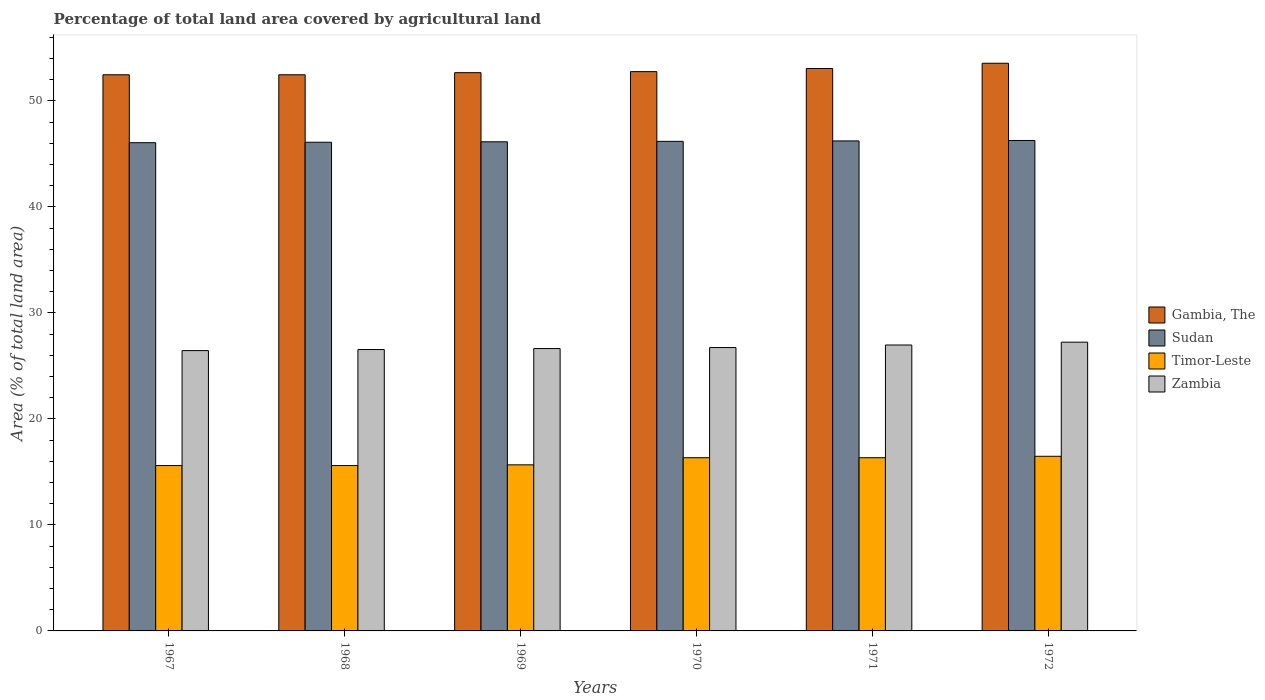Are the number of bars per tick equal to the number of legend labels?
Make the answer very short. Yes. Are the number of bars on each tick of the X-axis equal?
Give a very brief answer. Yes. How many bars are there on the 1st tick from the left?
Your response must be concise. 4. How many bars are there on the 2nd tick from the right?
Give a very brief answer. 4. What is the label of the 2nd group of bars from the left?
Provide a succinct answer. 1968. In how many cases, is the number of bars for a given year not equal to the number of legend labels?
Make the answer very short. 0. What is the percentage of agricultural land in Gambia, The in 1967?
Offer a very short reply. 52.47. Across all years, what is the maximum percentage of agricultural land in Gambia, The?
Offer a very short reply. 53.56. Across all years, what is the minimum percentage of agricultural land in Gambia, The?
Your answer should be very brief. 52.47. In which year was the percentage of agricultural land in Sudan minimum?
Provide a short and direct response. 1967. What is the total percentage of agricultural land in Gambia, The in the graph?
Offer a terse response. 317. What is the difference between the percentage of agricultural land in Zambia in 1967 and that in 1970?
Offer a very short reply. -0.29. What is the difference between the percentage of agricultural land in Sudan in 1968 and the percentage of agricultural land in Zambia in 1969?
Ensure brevity in your answer.  19.47. What is the average percentage of agricultural land in Zambia per year?
Your answer should be compact. 26.76. In the year 1967, what is the difference between the percentage of agricultural land in Sudan and percentage of agricultural land in Gambia, The?
Offer a terse response. -6.41. What is the ratio of the percentage of agricultural land in Sudan in 1971 to that in 1972?
Offer a terse response. 1. Is the percentage of agricultural land in Gambia, The in 1971 less than that in 1972?
Make the answer very short. Yes. What is the difference between the highest and the second highest percentage of agricultural land in Gambia, The?
Give a very brief answer. 0.49. What is the difference between the highest and the lowest percentage of agricultural land in Sudan?
Your answer should be very brief. 0.21. Is the sum of the percentage of agricultural land in Gambia, The in 1969 and 1972 greater than the maximum percentage of agricultural land in Timor-Leste across all years?
Ensure brevity in your answer.  Yes. Is it the case that in every year, the sum of the percentage of agricultural land in Zambia and percentage of agricultural land in Timor-Leste is greater than the sum of percentage of agricultural land in Sudan and percentage of agricultural land in Gambia, The?
Your answer should be very brief. No. What does the 3rd bar from the left in 1967 represents?
Ensure brevity in your answer.  Timor-Leste. What does the 1st bar from the right in 1969 represents?
Your answer should be compact. Zambia. Is it the case that in every year, the sum of the percentage of agricultural land in Sudan and percentage of agricultural land in Timor-Leste is greater than the percentage of agricultural land in Zambia?
Your response must be concise. Yes. How many bars are there?
Make the answer very short. 24. How many years are there in the graph?
Make the answer very short. 6. Are the values on the major ticks of Y-axis written in scientific E-notation?
Provide a succinct answer. No. How many legend labels are there?
Ensure brevity in your answer.  4. How are the legend labels stacked?
Your response must be concise. Vertical. What is the title of the graph?
Keep it short and to the point. Percentage of total land area covered by agricultural land. Does "Papua New Guinea" appear as one of the legend labels in the graph?
Keep it short and to the point. No. What is the label or title of the Y-axis?
Your answer should be very brief. Area (% of total land area). What is the Area (% of total land area) in Gambia, The in 1967?
Offer a very short reply. 52.47. What is the Area (% of total land area) in Sudan in 1967?
Provide a short and direct response. 46.06. What is the Area (% of total land area) of Timor-Leste in 1967?
Your response must be concise. 15.6. What is the Area (% of total land area) of Zambia in 1967?
Your answer should be very brief. 26.45. What is the Area (% of total land area) in Gambia, The in 1968?
Your answer should be compact. 52.47. What is the Area (% of total land area) in Sudan in 1968?
Offer a terse response. 46.11. What is the Area (% of total land area) in Timor-Leste in 1968?
Offer a terse response. 15.6. What is the Area (% of total land area) in Zambia in 1968?
Offer a very short reply. 26.55. What is the Area (% of total land area) in Gambia, The in 1969?
Provide a short and direct response. 52.67. What is the Area (% of total land area) in Sudan in 1969?
Your answer should be compact. 46.15. What is the Area (% of total land area) in Timor-Leste in 1969?
Ensure brevity in your answer.  15.67. What is the Area (% of total land area) of Zambia in 1969?
Your answer should be very brief. 26.64. What is the Area (% of total land area) of Gambia, The in 1970?
Give a very brief answer. 52.77. What is the Area (% of total land area) in Sudan in 1970?
Ensure brevity in your answer.  46.19. What is the Area (% of total land area) of Timor-Leste in 1970?
Ensure brevity in your answer.  16.34. What is the Area (% of total land area) of Zambia in 1970?
Your answer should be very brief. 26.73. What is the Area (% of total land area) of Gambia, The in 1971?
Give a very brief answer. 53.06. What is the Area (% of total land area) in Sudan in 1971?
Ensure brevity in your answer.  46.23. What is the Area (% of total land area) of Timor-Leste in 1971?
Provide a short and direct response. 16.34. What is the Area (% of total land area) in Zambia in 1971?
Keep it short and to the point. 26.98. What is the Area (% of total land area) in Gambia, The in 1972?
Make the answer very short. 53.56. What is the Area (% of total land area) of Sudan in 1972?
Make the answer very short. 46.27. What is the Area (% of total land area) of Timor-Leste in 1972?
Make the answer very short. 16.48. What is the Area (% of total land area) in Zambia in 1972?
Make the answer very short. 27.24. Across all years, what is the maximum Area (% of total land area) of Gambia, The?
Provide a short and direct response. 53.56. Across all years, what is the maximum Area (% of total land area) of Sudan?
Your answer should be very brief. 46.27. Across all years, what is the maximum Area (% of total land area) in Timor-Leste?
Make the answer very short. 16.48. Across all years, what is the maximum Area (% of total land area) of Zambia?
Ensure brevity in your answer.  27.24. Across all years, what is the minimum Area (% of total land area) in Gambia, The?
Give a very brief answer. 52.47. Across all years, what is the minimum Area (% of total land area) of Sudan?
Your answer should be compact. 46.06. Across all years, what is the minimum Area (% of total land area) in Timor-Leste?
Provide a succinct answer. 15.6. Across all years, what is the minimum Area (% of total land area) in Zambia?
Provide a succinct answer. 26.45. What is the total Area (% of total land area) of Gambia, The in the graph?
Make the answer very short. 317. What is the total Area (% of total land area) in Sudan in the graph?
Your answer should be compact. 277.01. What is the total Area (% of total land area) in Timor-Leste in the graph?
Provide a short and direct response. 96.03. What is the total Area (% of total land area) of Zambia in the graph?
Your answer should be compact. 160.59. What is the difference between the Area (% of total land area) in Sudan in 1967 and that in 1968?
Make the answer very short. -0.04. What is the difference between the Area (% of total land area) in Timor-Leste in 1967 and that in 1968?
Give a very brief answer. 0. What is the difference between the Area (% of total land area) in Zambia in 1967 and that in 1968?
Offer a very short reply. -0.1. What is the difference between the Area (% of total land area) of Gambia, The in 1967 and that in 1969?
Offer a very short reply. -0.2. What is the difference between the Area (% of total land area) of Sudan in 1967 and that in 1969?
Keep it short and to the point. -0.08. What is the difference between the Area (% of total land area) in Timor-Leste in 1967 and that in 1969?
Your response must be concise. -0.07. What is the difference between the Area (% of total land area) of Zambia in 1967 and that in 1969?
Your response must be concise. -0.19. What is the difference between the Area (% of total land area) in Gambia, The in 1967 and that in 1970?
Your answer should be compact. -0.3. What is the difference between the Area (% of total land area) in Sudan in 1967 and that in 1970?
Your answer should be very brief. -0.12. What is the difference between the Area (% of total land area) of Timor-Leste in 1967 and that in 1970?
Keep it short and to the point. -0.74. What is the difference between the Area (% of total land area) of Zambia in 1967 and that in 1970?
Give a very brief answer. -0.29. What is the difference between the Area (% of total land area) of Gambia, The in 1967 and that in 1971?
Give a very brief answer. -0.59. What is the difference between the Area (% of total land area) of Sudan in 1967 and that in 1971?
Give a very brief answer. -0.17. What is the difference between the Area (% of total land area) of Timor-Leste in 1967 and that in 1971?
Keep it short and to the point. -0.74. What is the difference between the Area (% of total land area) in Zambia in 1967 and that in 1971?
Make the answer very short. -0.53. What is the difference between the Area (% of total land area) in Gambia, The in 1967 and that in 1972?
Your response must be concise. -1.09. What is the difference between the Area (% of total land area) in Sudan in 1967 and that in 1972?
Offer a terse response. -0.21. What is the difference between the Area (% of total land area) in Timor-Leste in 1967 and that in 1972?
Keep it short and to the point. -0.87. What is the difference between the Area (% of total land area) of Zambia in 1967 and that in 1972?
Your answer should be compact. -0.79. What is the difference between the Area (% of total land area) in Gambia, The in 1968 and that in 1969?
Provide a succinct answer. -0.2. What is the difference between the Area (% of total land area) in Sudan in 1968 and that in 1969?
Your response must be concise. -0.04. What is the difference between the Area (% of total land area) in Timor-Leste in 1968 and that in 1969?
Ensure brevity in your answer.  -0.07. What is the difference between the Area (% of total land area) in Zambia in 1968 and that in 1969?
Ensure brevity in your answer.  -0.09. What is the difference between the Area (% of total land area) of Gambia, The in 1968 and that in 1970?
Your response must be concise. -0.3. What is the difference between the Area (% of total land area) in Sudan in 1968 and that in 1970?
Your answer should be compact. -0.08. What is the difference between the Area (% of total land area) in Timor-Leste in 1968 and that in 1970?
Your response must be concise. -0.74. What is the difference between the Area (% of total land area) of Zambia in 1968 and that in 1970?
Provide a succinct answer. -0.19. What is the difference between the Area (% of total land area) of Gambia, The in 1968 and that in 1971?
Offer a terse response. -0.59. What is the difference between the Area (% of total land area) in Sudan in 1968 and that in 1971?
Your response must be concise. -0.12. What is the difference between the Area (% of total land area) of Timor-Leste in 1968 and that in 1971?
Offer a terse response. -0.74. What is the difference between the Area (% of total land area) in Zambia in 1968 and that in 1971?
Give a very brief answer. -0.43. What is the difference between the Area (% of total land area) of Gambia, The in 1968 and that in 1972?
Offer a terse response. -1.09. What is the difference between the Area (% of total land area) in Sudan in 1968 and that in 1972?
Ensure brevity in your answer.  -0.17. What is the difference between the Area (% of total land area) of Timor-Leste in 1968 and that in 1972?
Your answer should be compact. -0.87. What is the difference between the Area (% of total land area) in Zambia in 1968 and that in 1972?
Provide a short and direct response. -0.69. What is the difference between the Area (% of total land area) of Gambia, The in 1969 and that in 1970?
Make the answer very short. -0.1. What is the difference between the Area (% of total land area) in Sudan in 1969 and that in 1970?
Provide a succinct answer. -0.04. What is the difference between the Area (% of total land area) in Timor-Leste in 1969 and that in 1970?
Your answer should be compact. -0.67. What is the difference between the Area (% of total land area) of Zambia in 1969 and that in 1970?
Make the answer very short. -0.09. What is the difference between the Area (% of total land area) of Gambia, The in 1969 and that in 1971?
Provide a succinct answer. -0.4. What is the difference between the Area (% of total land area) in Sudan in 1969 and that in 1971?
Make the answer very short. -0.08. What is the difference between the Area (% of total land area) of Timor-Leste in 1969 and that in 1971?
Your answer should be compact. -0.67. What is the difference between the Area (% of total land area) in Zambia in 1969 and that in 1971?
Keep it short and to the point. -0.34. What is the difference between the Area (% of total land area) of Gambia, The in 1969 and that in 1972?
Offer a terse response. -0.89. What is the difference between the Area (% of total land area) in Sudan in 1969 and that in 1972?
Provide a succinct answer. -0.12. What is the difference between the Area (% of total land area) in Timor-Leste in 1969 and that in 1972?
Provide a short and direct response. -0.81. What is the difference between the Area (% of total land area) in Zambia in 1969 and that in 1972?
Offer a very short reply. -0.6. What is the difference between the Area (% of total land area) of Gambia, The in 1970 and that in 1971?
Ensure brevity in your answer.  -0.3. What is the difference between the Area (% of total land area) of Sudan in 1970 and that in 1971?
Make the answer very short. -0.04. What is the difference between the Area (% of total land area) of Timor-Leste in 1970 and that in 1971?
Make the answer very short. 0. What is the difference between the Area (% of total land area) in Zambia in 1970 and that in 1971?
Provide a succinct answer. -0.24. What is the difference between the Area (% of total land area) of Gambia, The in 1970 and that in 1972?
Your response must be concise. -0.79. What is the difference between the Area (% of total land area) of Sudan in 1970 and that in 1972?
Keep it short and to the point. -0.08. What is the difference between the Area (% of total land area) of Timor-Leste in 1970 and that in 1972?
Give a very brief answer. -0.13. What is the difference between the Area (% of total land area) of Zambia in 1970 and that in 1972?
Provide a succinct answer. -0.51. What is the difference between the Area (% of total land area) of Gambia, The in 1971 and that in 1972?
Offer a very short reply. -0.49. What is the difference between the Area (% of total land area) in Sudan in 1971 and that in 1972?
Keep it short and to the point. -0.04. What is the difference between the Area (% of total land area) of Timor-Leste in 1971 and that in 1972?
Your response must be concise. -0.13. What is the difference between the Area (% of total land area) of Zambia in 1971 and that in 1972?
Provide a succinct answer. -0.27. What is the difference between the Area (% of total land area) in Gambia, The in 1967 and the Area (% of total land area) in Sudan in 1968?
Your response must be concise. 6.36. What is the difference between the Area (% of total land area) in Gambia, The in 1967 and the Area (% of total land area) in Timor-Leste in 1968?
Offer a very short reply. 36.87. What is the difference between the Area (% of total land area) in Gambia, The in 1967 and the Area (% of total land area) in Zambia in 1968?
Offer a very short reply. 25.92. What is the difference between the Area (% of total land area) in Sudan in 1967 and the Area (% of total land area) in Timor-Leste in 1968?
Your answer should be very brief. 30.46. What is the difference between the Area (% of total land area) of Sudan in 1967 and the Area (% of total land area) of Zambia in 1968?
Give a very brief answer. 19.52. What is the difference between the Area (% of total land area) in Timor-Leste in 1967 and the Area (% of total land area) in Zambia in 1968?
Keep it short and to the point. -10.95. What is the difference between the Area (% of total land area) in Gambia, The in 1967 and the Area (% of total land area) in Sudan in 1969?
Make the answer very short. 6.32. What is the difference between the Area (% of total land area) in Gambia, The in 1967 and the Area (% of total land area) in Timor-Leste in 1969?
Your answer should be compact. 36.8. What is the difference between the Area (% of total land area) in Gambia, The in 1967 and the Area (% of total land area) in Zambia in 1969?
Offer a very short reply. 25.83. What is the difference between the Area (% of total land area) in Sudan in 1967 and the Area (% of total land area) in Timor-Leste in 1969?
Provide a short and direct response. 30.4. What is the difference between the Area (% of total land area) of Sudan in 1967 and the Area (% of total land area) of Zambia in 1969?
Ensure brevity in your answer.  19.42. What is the difference between the Area (% of total land area) in Timor-Leste in 1967 and the Area (% of total land area) in Zambia in 1969?
Ensure brevity in your answer.  -11.04. What is the difference between the Area (% of total land area) in Gambia, The in 1967 and the Area (% of total land area) in Sudan in 1970?
Keep it short and to the point. 6.28. What is the difference between the Area (% of total land area) in Gambia, The in 1967 and the Area (% of total land area) in Timor-Leste in 1970?
Keep it short and to the point. 36.13. What is the difference between the Area (% of total land area) in Gambia, The in 1967 and the Area (% of total land area) in Zambia in 1970?
Provide a short and direct response. 25.74. What is the difference between the Area (% of total land area) of Sudan in 1967 and the Area (% of total land area) of Timor-Leste in 1970?
Make the answer very short. 29.72. What is the difference between the Area (% of total land area) of Sudan in 1967 and the Area (% of total land area) of Zambia in 1970?
Give a very brief answer. 19.33. What is the difference between the Area (% of total land area) in Timor-Leste in 1967 and the Area (% of total land area) in Zambia in 1970?
Offer a very short reply. -11.13. What is the difference between the Area (% of total land area) of Gambia, The in 1967 and the Area (% of total land area) of Sudan in 1971?
Ensure brevity in your answer.  6.24. What is the difference between the Area (% of total land area) in Gambia, The in 1967 and the Area (% of total land area) in Timor-Leste in 1971?
Ensure brevity in your answer.  36.13. What is the difference between the Area (% of total land area) of Gambia, The in 1967 and the Area (% of total land area) of Zambia in 1971?
Your answer should be very brief. 25.5. What is the difference between the Area (% of total land area) in Sudan in 1967 and the Area (% of total land area) in Timor-Leste in 1971?
Offer a terse response. 29.72. What is the difference between the Area (% of total land area) of Sudan in 1967 and the Area (% of total land area) of Zambia in 1971?
Your response must be concise. 19.09. What is the difference between the Area (% of total land area) of Timor-Leste in 1967 and the Area (% of total land area) of Zambia in 1971?
Offer a terse response. -11.37. What is the difference between the Area (% of total land area) in Gambia, The in 1967 and the Area (% of total land area) in Sudan in 1972?
Give a very brief answer. 6.2. What is the difference between the Area (% of total land area) in Gambia, The in 1967 and the Area (% of total land area) in Timor-Leste in 1972?
Your response must be concise. 35.99. What is the difference between the Area (% of total land area) in Gambia, The in 1967 and the Area (% of total land area) in Zambia in 1972?
Make the answer very short. 25.23. What is the difference between the Area (% of total land area) in Sudan in 1967 and the Area (% of total land area) in Timor-Leste in 1972?
Offer a terse response. 29.59. What is the difference between the Area (% of total land area) in Sudan in 1967 and the Area (% of total land area) in Zambia in 1972?
Offer a very short reply. 18.82. What is the difference between the Area (% of total land area) of Timor-Leste in 1967 and the Area (% of total land area) of Zambia in 1972?
Give a very brief answer. -11.64. What is the difference between the Area (% of total land area) in Gambia, The in 1968 and the Area (% of total land area) in Sudan in 1969?
Offer a very short reply. 6.32. What is the difference between the Area (% of total land area) of Gambia, The in 1968 and the Area (% of total land area) of Timor-Leste in 1969?
Your answer should be compact. 36.8. What is the difference between the Area (% of total land area) of Gambia, The in 1968 and the Area (% of total land area) of Zambia in 1969?
Your answer should be compact. 25.83. What is the difference between the Area (% of total land area) of Sudan in 1968 and the Area (% of total land area) of Timor-Leste in 1969?
Keep it short and to the point. 30.44. What is the difference between the Area (% of total land area) in Sudan in 1968 and the Area (% of total land area) in Zambia in 1969?
Provide a short and direct response. 19.47. What is the difference between the Area (% of total land area) in Timor-Leste in 1968 and the Area (% of total land area) in Zambia in 1969?
Provide a succinct answer. -11.04. What is the difference between the Area (% of total land area) of Gambia, The in 1968 and the Area (% of total land area) of Sudan in 1970?
Keep it short and to the point. 6.28. What is the difference between the Area (% of total land area) in Gambia, The in 1968 and the Area (% of total land area) in Timor-Leste in 1970?
Offer a terse response. 36.13. What is the difference between the Area (% of total land area) in Gambia, The in 1968 and the Area (% of total land area) in Zambia in 1970?
Offer a terse response. 25.74. What is the difference between the Area (% of total land area) of Sudan in 1968 and the Area (% of total land area) of Timor-Leste in 1970?
Your answer should be compact. 29.76. What is the difference between the Area (% of total land area) of Sudan in 1968 and the Area (% of total land area) of Zambia in 1970?
Offer a terse response. 19.37. What is the difference between the Area (% of total land area) in Timor-Leste in 1968 and the Area (% of total land area) in Zambia in 1970?
Your response must be concise. -11.13. What is the difference between the Area (% of total land area) in Gambia, The in 1968 and the Area (% of total land area) in Sudan in 1971?
Make the answer very short. 6.24. What is the difference between the Area (% of total land area) of Gambia, The in 1968 and the Area (% of total land area) of Timor-Leste in 1971?
Provide a succinct answer. 36.13. What is the difference between the Area (% of total land area) in Gambia, The in 1968 and the Area (% of total land area) in Zambia in 1971?
Your answer should be very brief. 25.5. What is the difference between the Area (% of total land area) in Sudan in 1968 and the Area (% of total land area) in Timor-Leste in 1971?
Offer a terse response. 29.76. What is the difference between the Area (% of total land area) of Sudan in 1968 and the Area (% of total land area) of Zambia in 1971?
Give a very brief answer. 19.13. What is the difference between the Area (% of total land area) of Timor-Leste in 1968 and the Area (% of total land area) of Zambia in 1971?
Offer a terse response. -11.37. What is the difference between the Area (% of total land area) of Gambia, The in 1968 and the Area (% of total land area) of Sudan in 1972?
Make the answer very short. 6.2. What is the difference between the Area (% of total land area) of Gambia, The in 1968 and the Area (% of total land area) of Timor-Leste in 1972?
Offer a very short reply. 35.99. What is the difference between the Area (% of total land area) of Gambia, The in 1968 and the Area (% of total land area) of Zambia in 1972?
Your answer should be compact. 25.23. What is the difference between the Area (% of total land area) of Sudan in 1968 and the Area (% of total land area) of Timor-Leste in 1972?
Your answer should be compact. 29.63. What is the difference between the Area (% of total land area) in Sudan in 1968 and the Area (% of total land area) in Zambia in 1972?
Ensure brevity in your answer.  18.86. What is the difference between the Area (% of total land area) of Timor-Leste in 1968 and the Area (% of total land area) of Zambia in 1972?
Provide a short and direct response. -11.64. What is the difference between the Area (% of total land area) of Gambia, The in 1969 and the Area (% of total land area) of Sudan in 1970?
Your answer should be very brief. 6.48. What is the difference between the Area (% of total land area) in Gambia, The in 1969 and the Area (% of total land area) in Timor-Leste in 1970?
Make the answer very short. 36.33. What is the difference between the Area (% of total land area) in Gambia, The in 1969 and the Area (% of total land area) in Zambia in 1970?
Give a very brief answer. 25.93. What is the difference between the Area (% of total land area) of Sudan in 1969 and the Area (% of total land area) of Timor-Leste in 1970?
Your response must be concise. 29.81. What is the difference between the Area (% of total land area) in Sudan in 1969 and the Area (% of total land area) in Zambia in 1970?
Your response must be concise. 19.41. What is the difference between the Area (% of total land area) in Timor-Leste in 1969 and the Area (% of total land area) in Zambia in 1970?
Your response must be concise. -11.07. What is the difference between the Area (% of total land area) of Gambia, The in 1969 and the Area (% of total land area) of Sudan in 1971?
Offer a very short reply. 6.44. What is the difference between the Area (% of total land area) of Gambia, The in 1969 and the Area (% of total land area) of Timor-Leste in 1971?
Your answer should be very brief. 36.33. What is the difference between the Area (% of total land area) of Gambia, The in 1969 and the Area (% of total land area) of Zambia in 1971?
Offer a terse response. 25.69. What is the difference between the Area (% of total land area) of Sudan in 1969 and the Area (% of total land area) of Timor-Leste in 1971?
Your answer should be compact. 29.81. What is the difference between the Area (% of total land area) of Sudan in 1969 and the Area (% of total land area) of Zambia in 1971?
Your response must be concise. 19.17. What is the difference between the Area (% of total land area) in Timor-Leste in 1969 and the Area (% of total land area) in Zambia in 1971?
Your answer should be very brief. -11.31. What is the difference between the Area (% of total land area) in Gambia, The in 1969 and the Area (% of total land area) in Sudan in 1972?
Your response must be concise. 6.4. What is the difference between the Area (% of total land area) in Gambia, The in 1969 and the Area (% of total land area) in Timor-Leste in 1972?
Make the answer very short. 36.19. What is the difference between the Area (% of total land area) of Gambia, The in 1969 and the Area (% of total land area) of Zambia in 1972?
Provide a succinct answer. 25.43. What is the difference between the Area (% of total land area) in Sudan in 1969 and the Area (% of total land area) in Timor-Leste in 1972?
Give a very brief answer. 29.67. What is the difference between the Area (% of total land area) in Sudan in 1969 and the Area (% of total land area) in Zambia in 1972?
Keep it short and to the point. 18.91. What is the difference between the Area (% of total land area) of Timor-Leste in 1969 and the Area (% of total land area) of Zambia in 1972?
Ensure brevity in your answer.  -11.57. What is the difference between the Area (% of total land area) of Gambia, The in 1970 and the Area (% of total land area) of Sudan in 1971?
Provide a succinct answer. 6.54. What is the difference between the Area (% of total land area) in Gambia, The in 1970 and the Area (% of total land area) in Timor-Leste in 1971?
Make the answer very short. 36.43. What is the difference between the Area (% of total land area) in Gambia, The in 1970 and the Area (% of total land area) in Zambia in 1971?
Your response must be concise. 25.79. What is the difference between the Area (% of total land area) of Sudan in 1970 and the Area (% of total land area) of Timor-Leste in 1971?
Provide a short and direct response. 29.85. What is the difference between the Area (% of total land area) of Sudan in 1970 and the Area (% of total land area) of Zambia in 1971?
Make the answer very short. 19.21. What is the difference between the Area (% of total land area) of Timor-Leste in 1970 and the Area (% of total land area) of Zambia in 1971?
Make the answer very short. -10.63. What is the difference between the Area (% of total land area) of Gambia, The in 1970 and the Area (% of total land area) of Sudan in 1972?
Offer a very short reply. 6.5. What is the difference between the Area (% of total land area) of Gambia, The in 1970 and the Area (% of total land area) of Timor-Leste in 1972?
Your response must be concise. 36.29. What is the difference between the Area (% of total land area) of Gambia, The in 1970 and the Area (% of total land area) of Zambia in 1972?
Give a very brief answer. 25.53. What is the difference between the Area (% of total land area) in Sudan in 1970 and the Area (% of total land area) in Timor-Leste in 1972?
Make the answer very short. 29.71. What is the difference between the Area (% of total land area) in Sudan in 1970 and the Area (% of total land area) in Zambia in 1972?
Make the answer very short. 18.95. What is the difference between the Area (% of total land area) of Timor-Leste in 1970 and the Area (% of total land area) of Zambia in 1972?
Your response must be concise. -10.9. What is the difference between the Area (% of total land area) of Gambia, The in 1971 and the Area (% of total land area) of Sudan in 1972?
Provide a succinct answer. 6.79. What is the difference between the Area (% of total land area) in Gambia, The in 1971 and the Area (% of total land area) in Timor-Leste in 1972?
Ensure brevity in your answer.  36.59. What is the difference between the Area (% of total land area) in Gambia, The in 1971 and the Area (% of total land area) in Zambia in 1972?
Provide a short and direct response. 25.82. What is the difference between the Area (% of total land area) of Sudan in 1971 and the Area (% of total land area) of Timor-Leste in 1972?
Ensure brevity in your answer.  29.75. What is the difference between the Area (% of total land area) of Sudan in 1971 and the Area (% of total land area) of Zambia in 1972?
Provide a succinct answer. 18.99. What is the difference between the Area (% of total land area) in Timor-Leste in 1971 and the Area (% of total land area) in Zambia in 1972?
Provide a succinct answer. -10.9. What is the average Area (% of total land area) of Gambia, The per year?
Offer a terse response. 52.83. What is the average Area (% of total land area) of Sudan per year?
Keep it short and to the point. 46.17. What is the average Area (% of total land area) in Timor-Leste per year?
Provide a succinct answer. 16.01. What is the average Area (% of total land area) of Zambia per year?
Give a very brief answer. 26.76. In the year 1967, what is the difference between the Area (% of total land area) in Gambia, The and Area (% of total land area) in Sudan?
Keep it short and to the point. 6.41. In the year 1967, what is the difference between the Area (% of total land area) of Gambia, The and Area (% of total land area) of Timor-Leste?
Offer a very short reply. 36.87. In the year 1967, what is the difference between the Area (% of total land area) in Gambia, The and Area (% of total land area) in Zambia?
Offer a terse response. 26.02. In the year 1967, what is the difference between the Area (% of total land area) in Sudan and Area (% of total land area) in Timor-Leste?
Offer a terse response. 30.46. In the year 1967, what is the difference between the Area (% of total land area) in Sudan and Area (% of total land area) in Zambia?
Your answer should be very brief. 19.62. In the year 1967, what is the difference between the Area (% of total land area) in Timor-Leste and Area (% of total land area) in Zambia?
Offer a very short reply. -10.85. In the year 1968, what is the difference between the Area (% of total land area) of Gambia, The and Area (% of total land area) of Sudan?
Give a very brief answer. 6.36. In the year 1968, what is the difference between the Area (% of total land area) in Gambia, The and Area (% of total land area) in Timor-Leste?
Provide a short and direct response. 36.87. In the year 1968, what is the difference between the Area (% of total land area) of Gambia, The and Area (% of total land area) of Zambia?
Offer a very short reply. 25.92. In the year 1968, what is the difference between the Area (% of total land area) of Sudan and Area (% of total land area) of Timor-Leste?
Ensure brevity in your answer.  30.5. In the year 1968, what is the difference between the Area (% of total land area) of Sudan and Area (% of total land area) of Zambia?
Your answer should be very brief. 19.56. In the year 1968, what is the difference between the Area (% of total land area) of Timor-Leste and Area (% of total land area) of Zambia?
Offer a very short reply. -10.95. In the year 1969, what is the difference between the Area (% of total land area) in Gambia, The and Area (% of total land area) in Sudan?
Provide a short and direct response. 6.52. In the year 1969, what is the difference between the Area (% of total land area) of Gambia, The and Area (% of total land area) of Timor-Leste?
Offer a terse response. 37. In the year 1969, what is the difference between the Area (% of total land area) of Gambia, The and Area (% of total land area) of Zambia?
Your answer should be compact. 26.03. In the year 1969, what is the difference between the Area (% of total land area) in Sudan and Area (% of total land area) in Timor-Leste?
Ensure brevity in your answer.  30.48. In the year 1969, what is the difference between the Area (% of total land area) in Sudan and Area (% of total land area) in Zambia?
Your response must be concise. 19.51. In the year 1969, what is the difference between the Area (% of total land area) of Timor-Leste and Area (% of total land area) of Zambia?
Keep it short and to the point. -10.97. In the year 1970, what is the difference between the Area (% of total land area) in Gambia, The and Area (% of total land area) in Sudan?
Offer a very short reply. 6.58. In the year 1970, what is the difference between the Area (% of total land area) in Gambia, The and Area (% of total land area) in Timor-Leste?
Offer a very short reply. 36.43. In the year 1970, what is the difference between the Area (% of total land area) in Gambia, The and Area (% of total land area) in Zambia?
Give a very brief answer. 26.03. In the year 1970, what is the difference between the Area (% of total land area) in Sudan and Area (% of total land area) in Timor-Leste?
Your response must be concise. 29.85. In the year 1970, what is the difference between the Area (% of total land area) of Sudan and Area (% of total land area) of Zambia?
Make the answer very short. 19.45. In the year 1970, what is the difference between the Area (% of total land area) of Timor-Leste and Area (% of total land area) of Zambia?
Provide a short and direct response. -10.39. In the year 1971, what is the difference between the Area (% of total land area) of Gambia, The and Area (% of total land area) of Sudan?
Your response must be concise. 6.83. In the year 1971, what is the difference between the Area (% of total land area) of Gambia, The and Area (% of total land area) of Timor-Leste?
Your response must be concise. 36.72. In the year 1971, what is the difference between the Area (% of total land area) of Gambia, The and Area (% of total land area) of Zambia?
Provide a succinct answer. 26.09. In the year 1971, what is the difference between the Area (% of total land area) of Sudan and Area (% of total land area) of Timor-Leste?
Your answer should be very brief. 29.89. In the year 1971, what is the difference between the Area (% of total land area) of Sudan and Area (% of total land area) of Zambia?
Make the answer very short. 19.26. In the year 1971, what is the difference between the Area (% of total land area) of Timor-Leste and Area (% of total land area) of Zambia?
Provide a succinct answer. -10.63. In the year 1972, what is the difference between the Area (% of total land area) in Gambia, The and Area (% of total land area) in Sudan?
Offer a terse response. 7.29. In the year 1972, what is the difference between the Area (% of total land area) in Gambia, The and Area (% of total land area) in Timor-Leste?
Your response must be concise. 37.08. In the year 1972, what is the difference between the Area (% of total land area) of Gambia, The and Area (% of total land area) of Zambia?
Ensure brevity in your answer.  26.32. In the year 1972, what is the difference between the Area (% of total land area) of Sudan and Area (% of total land area) of Timor-Leste?
Your response must be concise. 29.8. In the year 1972, what is the difference between the Area (% of total land area) of Sudan and Area (% of total land area) of Zambia?
Ensure brevity in your answer.  19.03. In the year 1972, what is the difference between the Area (% of total land area) in Timor-Leste and Area (% of total land area) in Zambia?
Your answer should be very brief. -10.77. What is the ratio of the Area (% of total land area) of Gambia, The in 1967 to that in 1968?
Offer a terse response. 1. What is the ratio of the Area (% of total land area) in Timor-Leste in 1967 to that in 1968?
Your answer should be very brief. 1. What is the ratio of the Area (% of total land area) of Timor-Leste in 1967 to that in 1969?
Your response must be concise. 1. What is the ratio of the Area (% of total land area) of Zambia in 1967 to that in 1969?
Make the answer very short. 0.99. What is the ratio of the Area (% of total land area) of Gambia, The in 1967 to that in 1970?
Provide a short and direct response. 0.99. What is the ratio of the Area (% of total land area) in Sudan in 1967 to that in 1970?
Your answer should be compact. 1. What is the ratio of the Area (% of total land area) in Timor-Leste in 1967 to that in 1970?
Ensure brevity in your answer.  0.95. What is the ratio of the Area (% of total land area) in Zambia in 1967 to that in 1970?
Your response must be concise. 0.99. What is the ratio of the Area (% of total land area) of Sudan in 1967 to that in 1971?
Provide a short and direct response. 1. What is the ratio of the Area (% of total land area) of Timor-Leste in 1967 to that in 1971?
Provide a succinct answer. 0.95. What is the ratio of the Area (% of total land area) of Zambia in 1967 to that in 1971?
Provide a succinct answer. 0.98. What is the ratio of the Area (% of total land area) in Gambia, The in 1967 to that in 1972?
Keep it short and to the point. 0.98. What is the ratio of the Area (% of total land area) of Sudan in 1967 to that in 1972?
Offer a terse response. 1. What is the ratio of the Area (% of total land area) of Timor-Leste in 1967 to that in 1972?
Ensure brevity in your answer.  0.95. What is the ratio of the Area (% of total land area) of Zambia in 1967 to that in 1972?
Ensure brevity in your answer.  0.97. What is the ratio of the Area (% of total land area) in Timor-Leste in 1968 to that in 1969?
Your answer should be very brief. 1. What is the ratio of the Area (% of total land area) in Zambia in 1968 to that in 1969?
Your answer should be compact. 1. What is the ratio of the Area (% of total land area) in Sudan in 1968 to that in 1970?
Provide a short and direct response. 1. What is the ratio of the Area (% of total land area) in Timor-Leste in 1968 to that in 1970?
Offer a terse response. 0.95. What is the ratio of the Area (% of total land area) in Zambia in 1968 to that in 1970?
Make the answer very short. 0.99. What is the ratio of the Area (% of total land area) in Gambia, The in 1968 to that in 1971?
Keep it short and to the point. 0.99. What is the ratio of the Area (% of total land area) of Sudan in 1968 to that in 1971?
Make the answer very short. 1. What is the ratio of the Area (% of total land area) of Timor-Leste in 1968 to that in 1971?
Ensure brevity in your answer.  0.95. What is the ratio of the Area (% of total land area) of Zambia in 1968 to that in 1971?
Offer a terse response. 0.98. What is the ratio of the Area (% of total land area) of Gambia, The in 1968 to that in 1972?
Offer a terse response. 0.98. What is the ratio of the Area (% of total land area) in Timor-Leste in 1968 to that in 1972?
Your answer should be compact. 0.95. What is the ratio of the Area (% of total land area) of Zambia in 1968 to that in 1972?
Your response must be concise. 0.97. What is the ratio of the Area (% of total land area) in Sudan in 1969 to that in 1970?
Offer a very short reply. 1. What is the ratio of the Area (% of total land area) of Timor-Leste in 1969 to that in 1970?
Provide a succinct answer. 0.96. What is the ratio of the Area (% of total land area) in Gambia, The in 1969 to that in 1971?
Ensure brevity in your answer.  0.99. What is the ratio of the Area (% of total land area) of Sudan in 1969 to that in 1971?
Give a very brief answer. 1. What is the ratio of the Area (% of total land area) of Timor-Leste in 1969 to that in 1971?
Provide a succinct answer. 0.96. What is the ratio of the Area (% of total land area) in Zambia in 1969 to that in 1971?
Offer a terse response. 0.99. What is the ratio of the Area (% of total land area) in Gambia, The in 1969 to that in 1972?
Make the answer very short. 0.98. What is the ratio of the Area (% of total land area) of Sudan in 1969 to that in 1972?
Offer a very short reply. 1. What is the ratio of the Area (% of total land area) in Timor-Leste in 1969 to that in 1972?
Your answer should be compact. 0.95. What is the ratio of the Area (% of total land area) in Zambia in 1969 to that in 1972?
Give a very brief answer. 0.98. What is the ratio of the Area (% of total land area) in Timor-Leste in 1970 to that in 1971?
Keep it short and to the point. 1. What is the ratio of the Area (% of total land area) of Zambia in 1970 to that in 1971?
Make the answer very short. 0.99. What is the ratio of the Area (% of total land area) in Gambia, The in 1970 to that in 1972?
Your answer should be compact. 0.99. What is the ratio of the Area (% of total land area) in Sudan in 1970 to that in 1972?
Make the answer very short. 1. What is the ratio of the Area (% of total land area) in Zambia in 1970 to that in 1972?
Provide a short and direct response. 0.98. What is the ratio of the Area (% of total land area) in Gambia, The in 1971 to that in 1972?
Provide a succinct answer. 0.99. What is the ratio of the Area (% of total land area) in Zambia in 1971 to that in 1972?
Ensure brevity in your answer.  0.99. What is the difference between the highest and the second highest Area (% of total land area) in Gambia, The?
Your answer should be very brief. 0.49. What is the difference between the highest and the second highest Area (% of total land area) in Sudan?
Your answer should be very brief. 0.04. What is the difference between the highest and the second highest Area (% of total land area) in Timor-Leste?
Ensure brevity in your answer.  0.13. What is the difference between the highest and the second highest Area (% of total land area) in Zambia?
Your answer should be very brief. 0.27. What is the difference between the highest and the lowest Area (% of total land area) in Gambia, The?
Offer a very short reply. 1.09. What is the difference between the highest and the lowest Area (% of total land area) of Sudan?
Your answer should be very brief. 0.21. What is the difference between the highest and the lowest Area (% of total land area) of Timor-Leste?
Keep it short and to the point. 0.87. What is the difference between the highest and the lowest Area (% of total land area) of Zambia?
Provide a succinct answer. 0.79. 